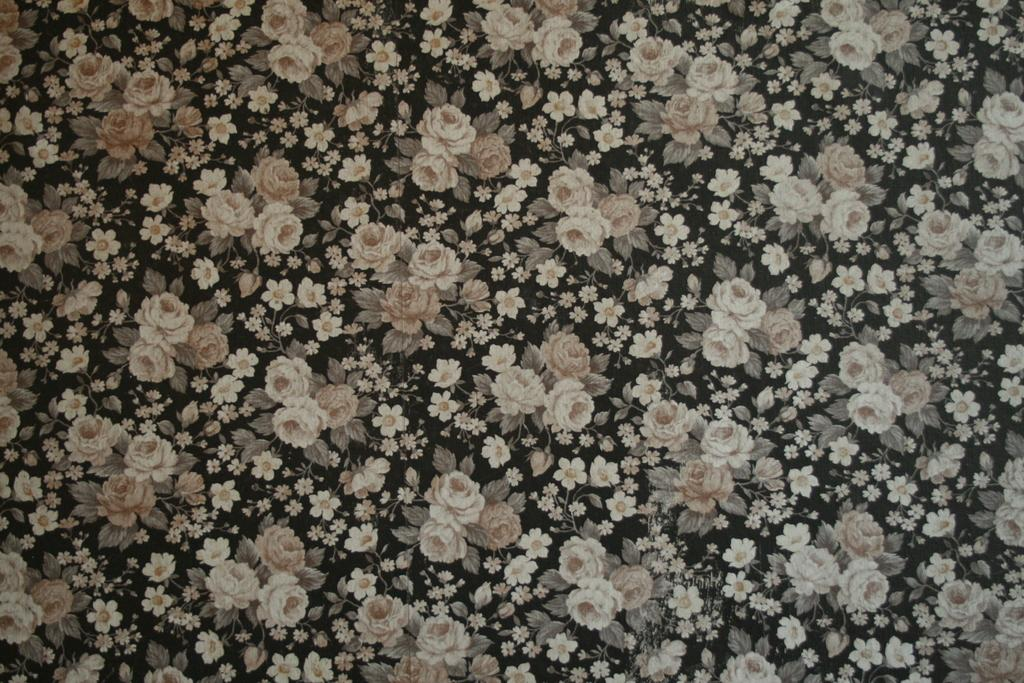What is the color of the fabric cloth in the image? The fabric cloth is black in color. Are there any designs or patterns on the fabric cloth? Yes, there are white color flowers printed on the fabric cloth. How many pigs can be seen inside the cave in the image? There is no cave or pigs present in the image; it features a black fabric cloth with white flowers printed on it. 